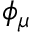Convert formula to latex. <formula><loc_0><loc_0><loc_500><loc_500>\phi _ { \mu }</formula> 